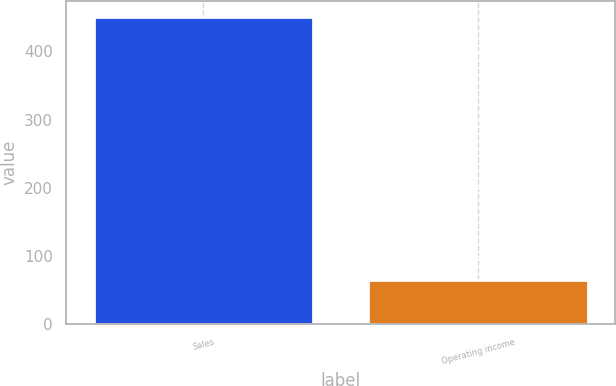<chart> <loc_0><loc_0><loc_500><loc_500><bar_chart><fcel>Sales<fcel>Operating income<nl><fcel>451.1<fcel>65.5<nl></chart> 